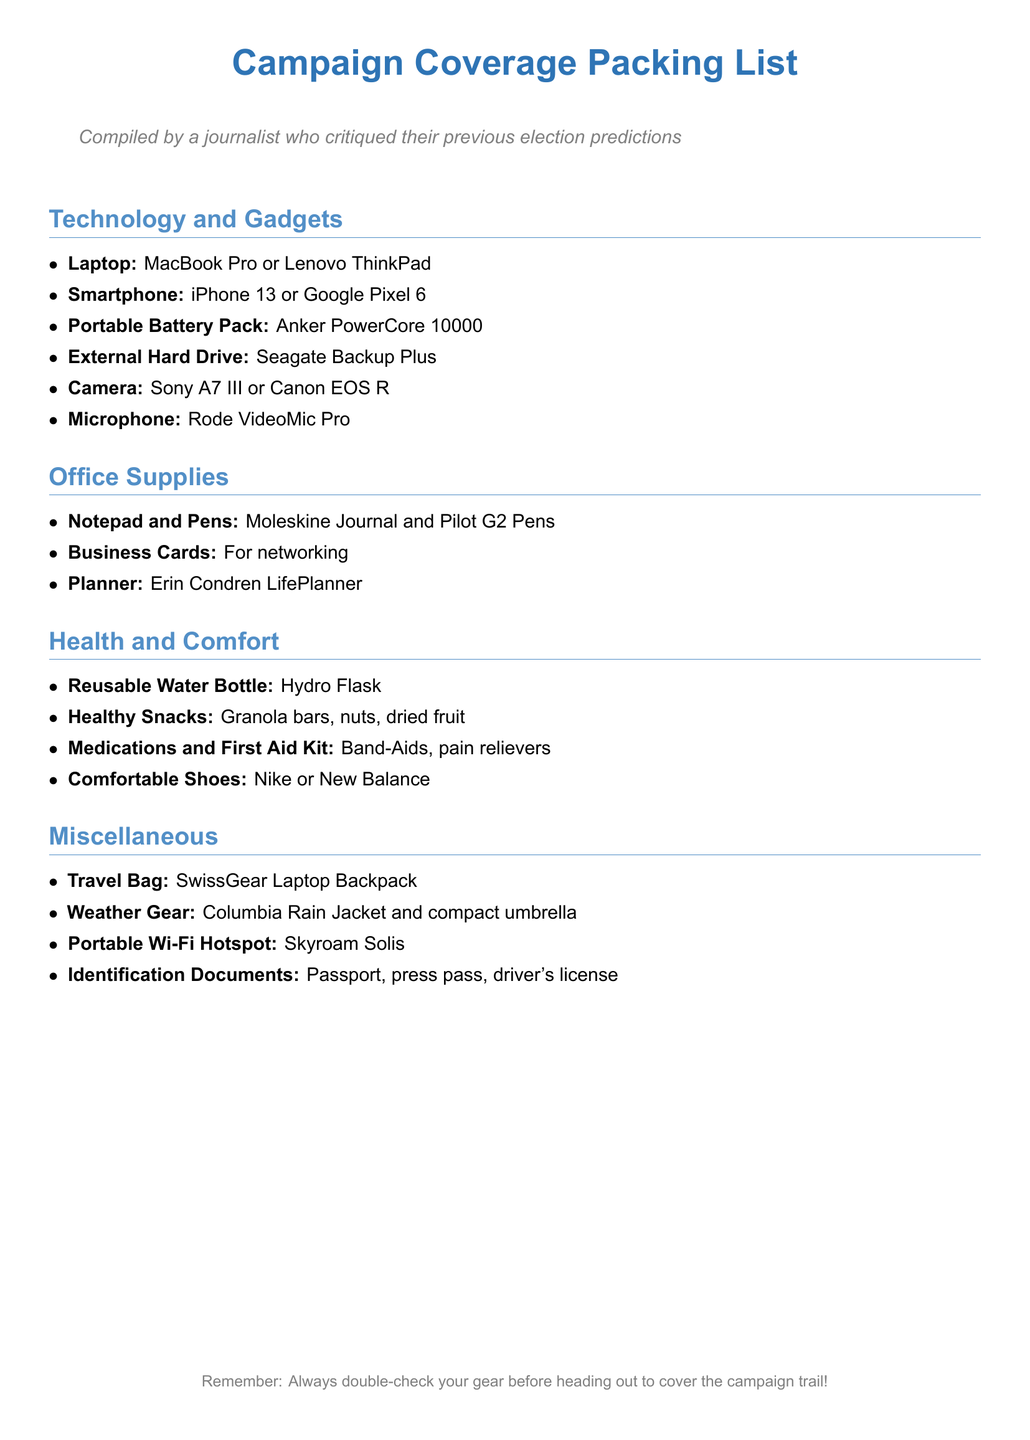What type of laptop is recommended? The document lists MacBook Pro or Lenovo ThinkPad as recommended laptops.
Answer: MacBook Pro or Lenovo ThinkPad What is included in the Health and Comfort section? The Health and Comfort section includes items such as a reusable water bottle and snacks.
Answer: Reusable Water Bottle, Healthy Snacks, Medications and First Aid Kit, Comfortable Shoes Which brand of external hard drive is suggested? The document specifies Seagate Backup Plus as the recommended external hard drive.
Answer: Seagate Backup Plus How many categories are in the packing list? The packing list is divided into four main categories: Technology and Gadgets, Office Supplies, Health and Comfort, Miscellaneous.
Answer: Four What specific microphone is mentioned in the Technology and Gadgets section? Rode VideoMic Pro is the only microphone mentioned in that section.
Answer: Rode VideoMic Pro What type of travel bag is recommended? A SwissGear Laptop Backpack is suggested as the travel bag.
Answer: SwissGear Laptop Backpack What kind of snacks are recommended? The document suggests healthy snacks like granola bars, nuts, and dried fruit.
Answer: Granola bars, nuts, dried fruit What is the color of the title in the document? The title color is defined by the RGB values in the document, which are specifically mentioned.
Answer: RGB(46,116,181) 